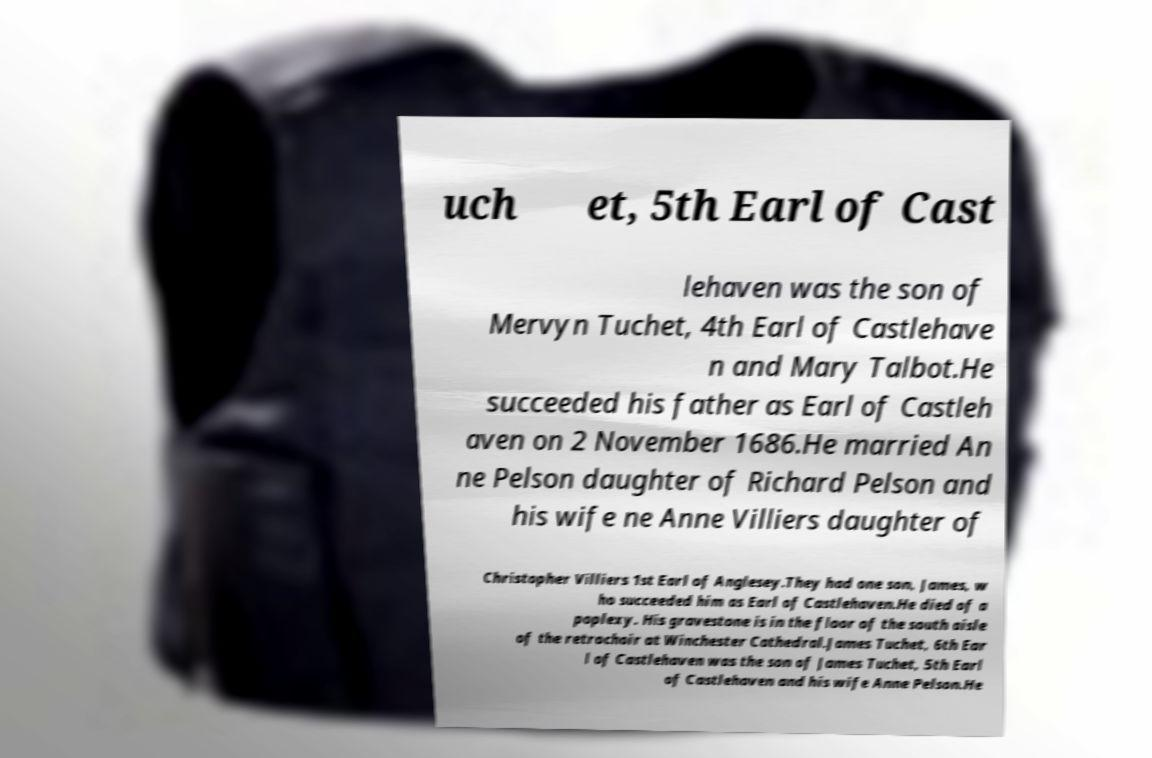Can you read and provide the text displayed in the image?This photo seems to have some interesting text. Can you extract and type it out for me? uch et, 5th Earl of Cast lehaven was the son of Mervyn Tuchet, 4th Earl of Castlehave n and Mary Talbot.He succeeded his father as Earl of Castleh aven on 2 November 1686.He married An ne Pelson daughter of Richard Pelson and his wife ne Anne Villiers daughter of Christopher Villiers 1st Earl of Anglesey.They had one son, James, w ho succeeded him as Earl of Castlehaven.He died of a poplexy. His gravestone is in the floor of the south aisle of the retrochoir at Winchester Cathedral.James Tuchet, 6th Ear l of Castlehaven was the son of James Tuchet, 5th Earl of Castlehaven and his wife Anne Pelson.He 